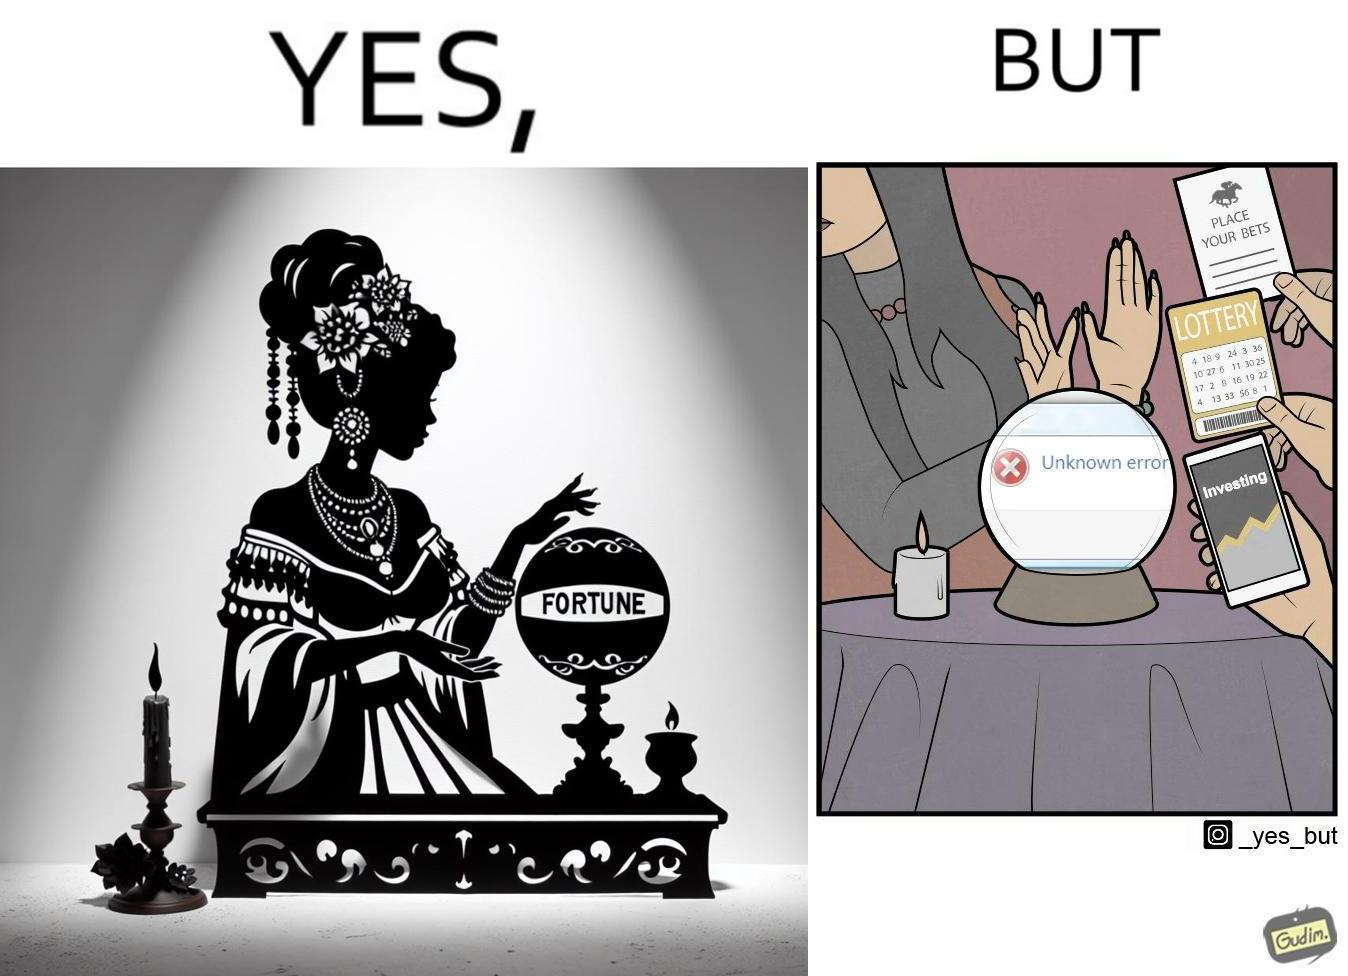Is this a satirical image? Yes, this image is satirical. 